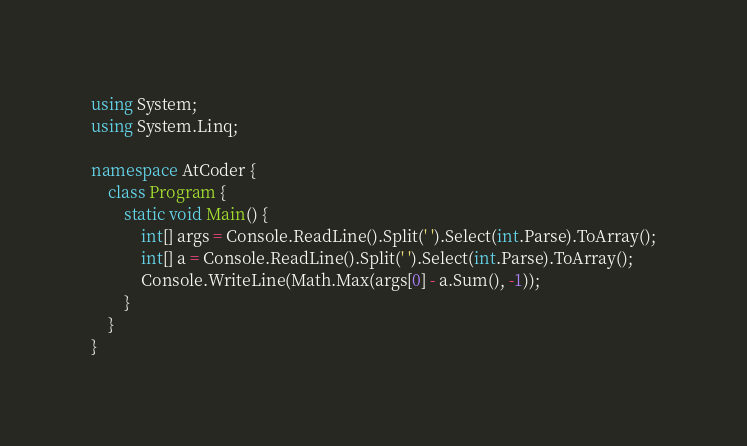Convert code to text. <code><loc_0><loc_0><loc_500><loc_500><_C#_>using System;
using System.Linq;

namespace AtCoder {
    class Program {
        static void Main() {
            int[] args = Console.ReadLine().Split(' ').Select(int.Parse).ToArray();
            int[] a = Console.ReadLine().Split(' ').Select(int.Parse).ToArray();
            Console.WriteLine(Math.Max(args[0] - a.Sum(), -1));
        }
    }
}</code> 